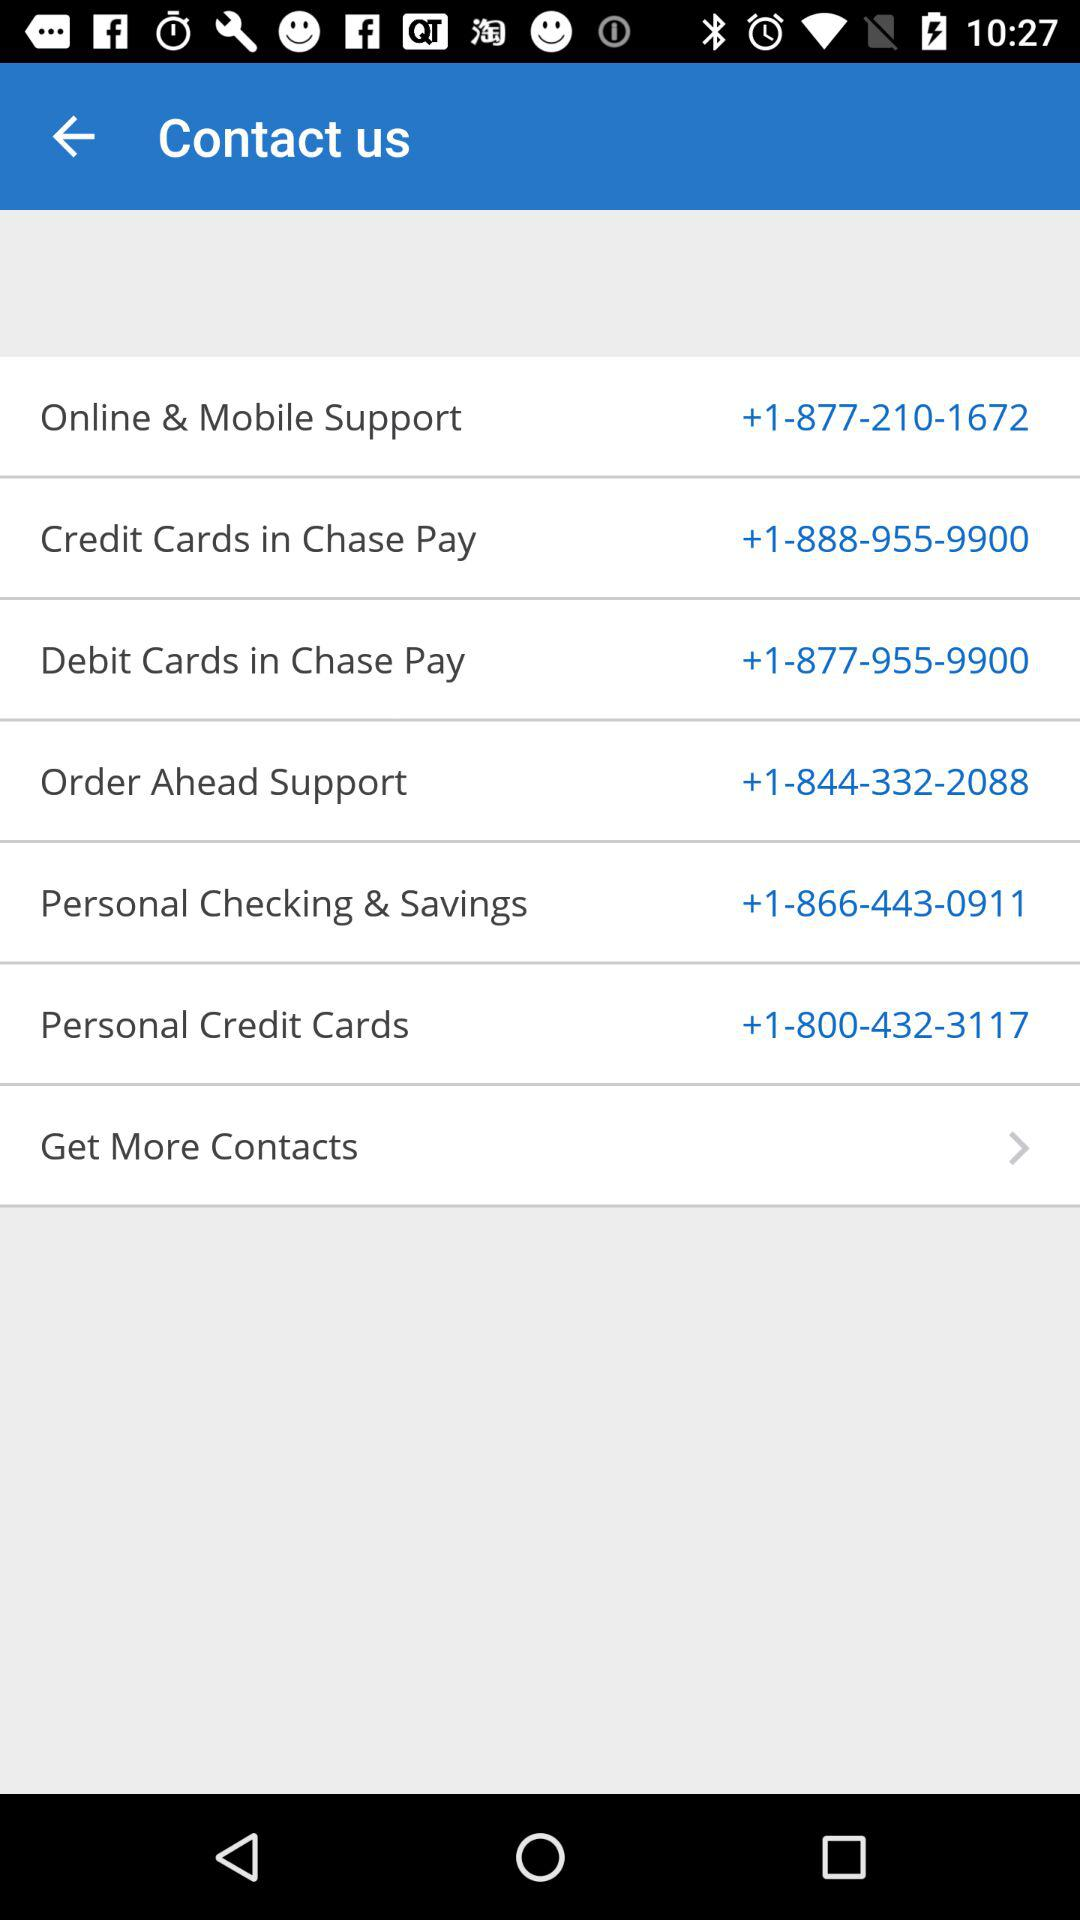What is the phone number for "Order Ahead Support"? The phone number is +1-844-332-2088. 